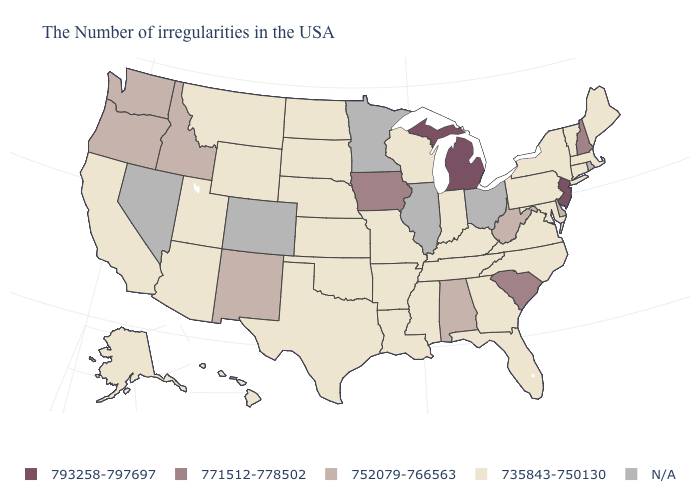Name the states that have a value in the range 735843-750130?
Write a very short answer. Maine, Massachusetts, Vermont, Connecticut, New York, Maryland, Pennsylvania, Virginia, North Carolina, Florida, Georgia, Kentucky, Indiana, Tennessee, Wisconsin, Mississippi, Louisiana, Missouri, Arkansas, Kansas, Nebraska, Oklahoma, Texas, South Dakota, North Dakota, Wyoming, Utah, Montana, Arizona, California, Alaska, Hawaii. What is the value of Rhode Island?
Concise answer only. N/A. Does Idaho have the highest value in the West?
Quick response, please. Yes. Does Michigan have the highest value in the USA?
Concise answer only. Yes. How many symbols are there in the legend?
Quick response, please. 5. What is the value of Nebraska?
Give a very brief answer. 735843-750130. What is the lowest value in states that border South Dakota?
Concise answer only. 735843-750130. What is the value of Hawaii?
Concise answer only. 735843-750130. Name the states that have a value in the range 735843-750130?
Quick response, please. Maine, Massachusetts, Vermont, Connecticut, New York, Maryland, Pennsylvania, Virginia, North Carolina, Florida, Georgia, Kentucky, Indiana, Tennessee, Wisconsin, Mississippi, Louisiana, Missouri, Arkansas, Kansas, Nebraska, Oklahoma, Texas, South Dakota, North Dakota, Wyoming, Utah, Montana, Arizona, California, Alaska, Hawaii. Is the legend a continuous bar?
Answer briefly. No. Does New Hampshire have the lowest value in the Northeast?
Concise answer only. No. What is the value of Nevada?
Short answer required. N/A. Among the states that border Idaho , does Montana have the highest value?
Give a very brief answer. No. What is the highest value in the MidWest ?
Keep it brief. 793258-797697. 